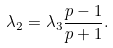<formula> <loc_0><loc_0><loc_500><loc_500>\lambda _ { 2 } = \lambda _ { 3 } \frac { p - 1 } { p + 1 } .</formula> 